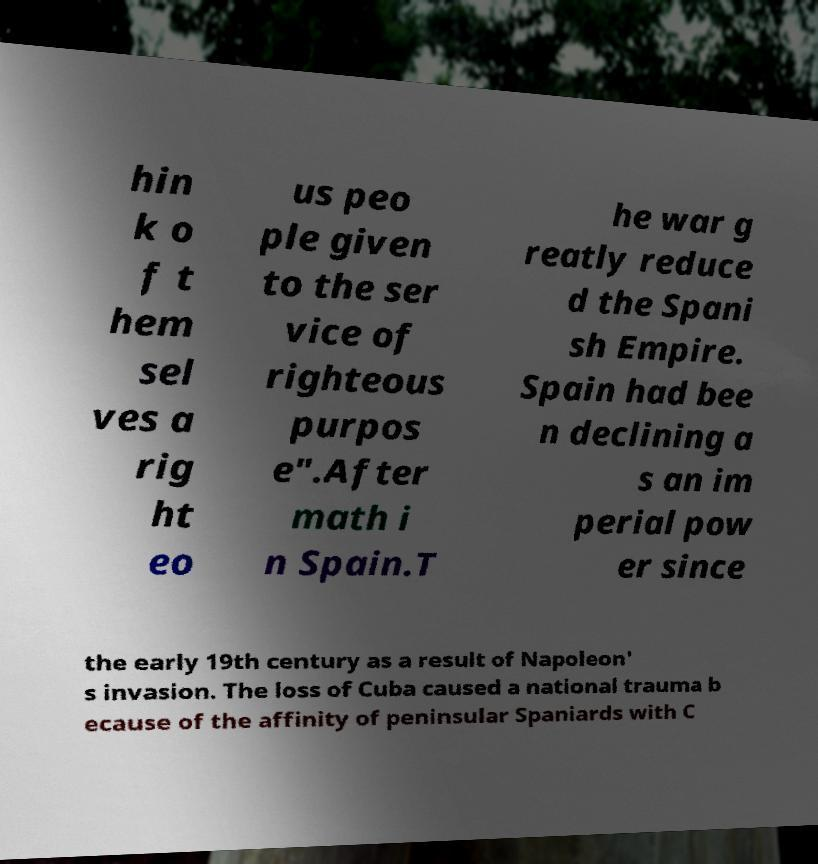Can you accurately transcribe the text from the provided image for me? hin k o f t hem sel ves a rig ht eo us peo ple given to the ser vice of righteous purpos e".After math i n Spain.T he war g reatly reduce d the Spani sh Empire. Spain had bee n declining a s an im perial pow er since the early 19th century as a result of Napoleon' s invasion. The loss of Cuba caused a national trauma b ecause of the affinity of peninsular Spaniards with C 